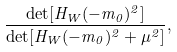<formula> <loc_0><loc_0><loc_500><loc_500>\frac { \det [ H _ { W } ( - m _ { 0 } ) ^ { 2 } ] } { \det [ H _ { W } ( - m _ { 0 } ) ^ { 2 } + \mu ^ { 2 } ] } ,</formula> 